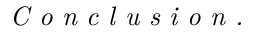<formula> <loc_0><loc_0><loc_500><loc_500>\emph { C o n c l u s i o n . }</formula> 